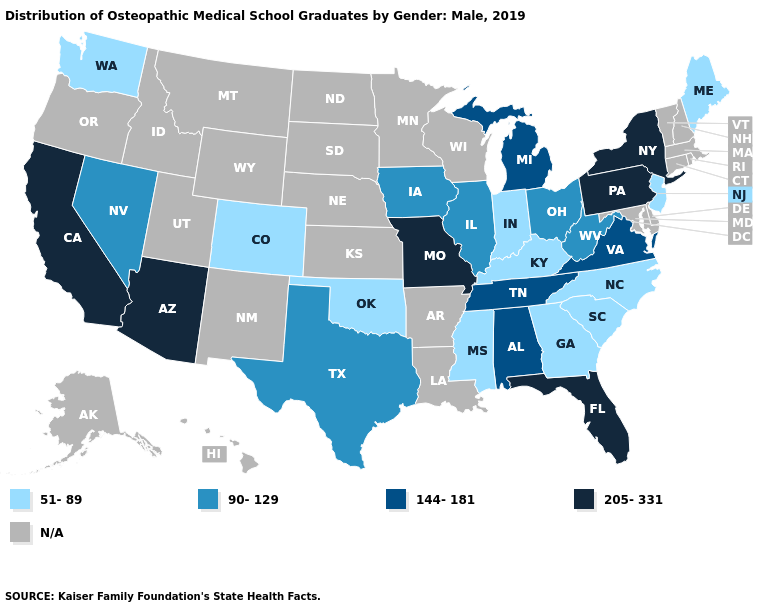Does Indiana have the lowest value in the MidWest?
Concise answer only. Yes. Which states have the lowest value in the USA?
Answer briefly. Colorado, Georgia, Indiana, Kentucky, Maine, Mississippi, New Jersey, North Carolina, Oklahoma, South Carolina, Washington. Is the legend a continuous bar?
Keep it brief. No. What is the value of Virginia?
Short answer required. 144-181. Name the states that have a value in the range 205-331?
Concise answer only. Arizona, California, Florida, Missouri, New York, Pennsylvania. Name the states that have a value in the range 90-129?
Be succinct. Illinois, Iowa, Nevada, Ohio, Texas, West Virginia. What is the value of Pennsylvania?
Quick response, please. 205-331. What is the lowest value in the USA?
Concise answer only. 51-89. What is the value of South Carolina?
Give a very brief answer. 51-89. Which states hav the highest value in the MidWest?
Answer briefly. Missouri. Which states have the highest value in the USA?
Keep it brief. Arizona, California, Florida, Missouri, New York, Pennsylvania. Name the states that have a value in the range 51-89?
Short answer required. Colorado, Georgia, Indiana, Kentucky, Maine, Mississippi, New Jersey, North Carolina, Oklahoma, South Carolina, Washington. Name the states that have a value in the range 90-129?
Keep it brief. Illinois, Iowa, Nevada, Ohio, Texas, West Virginia. 